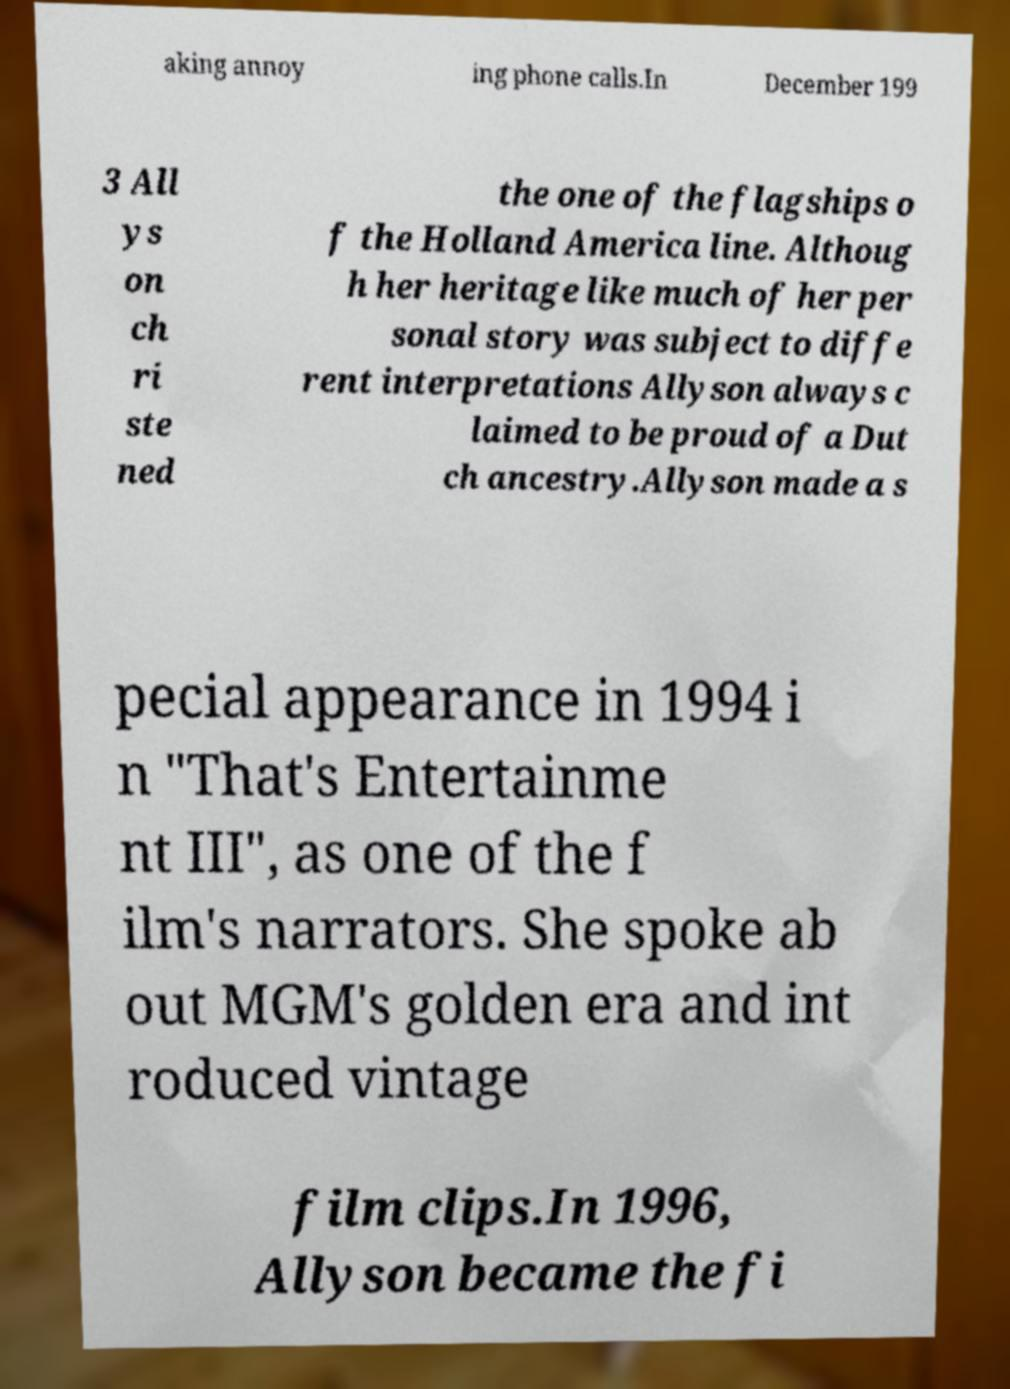What messages or text are displayed in this image? I need them in a readable, typed format. aking annoy ing phone calls.In December 199 3 All ys on ch ri ste ned the one of the flagships o f the Holland America line. Althoug h her heritage like much of her per sonal story was subject to diffe rent interpretations Allyson always c laimed to be proud of a Dut ch ancestry.Allyson made a s pecial appearance in 1994 i n "That's Entertainme nt III", as one of the f ilm's narrators. She spoke ab out MGM's golden era and int roduced vintage film clips.In 1996, Allyson became the fi 